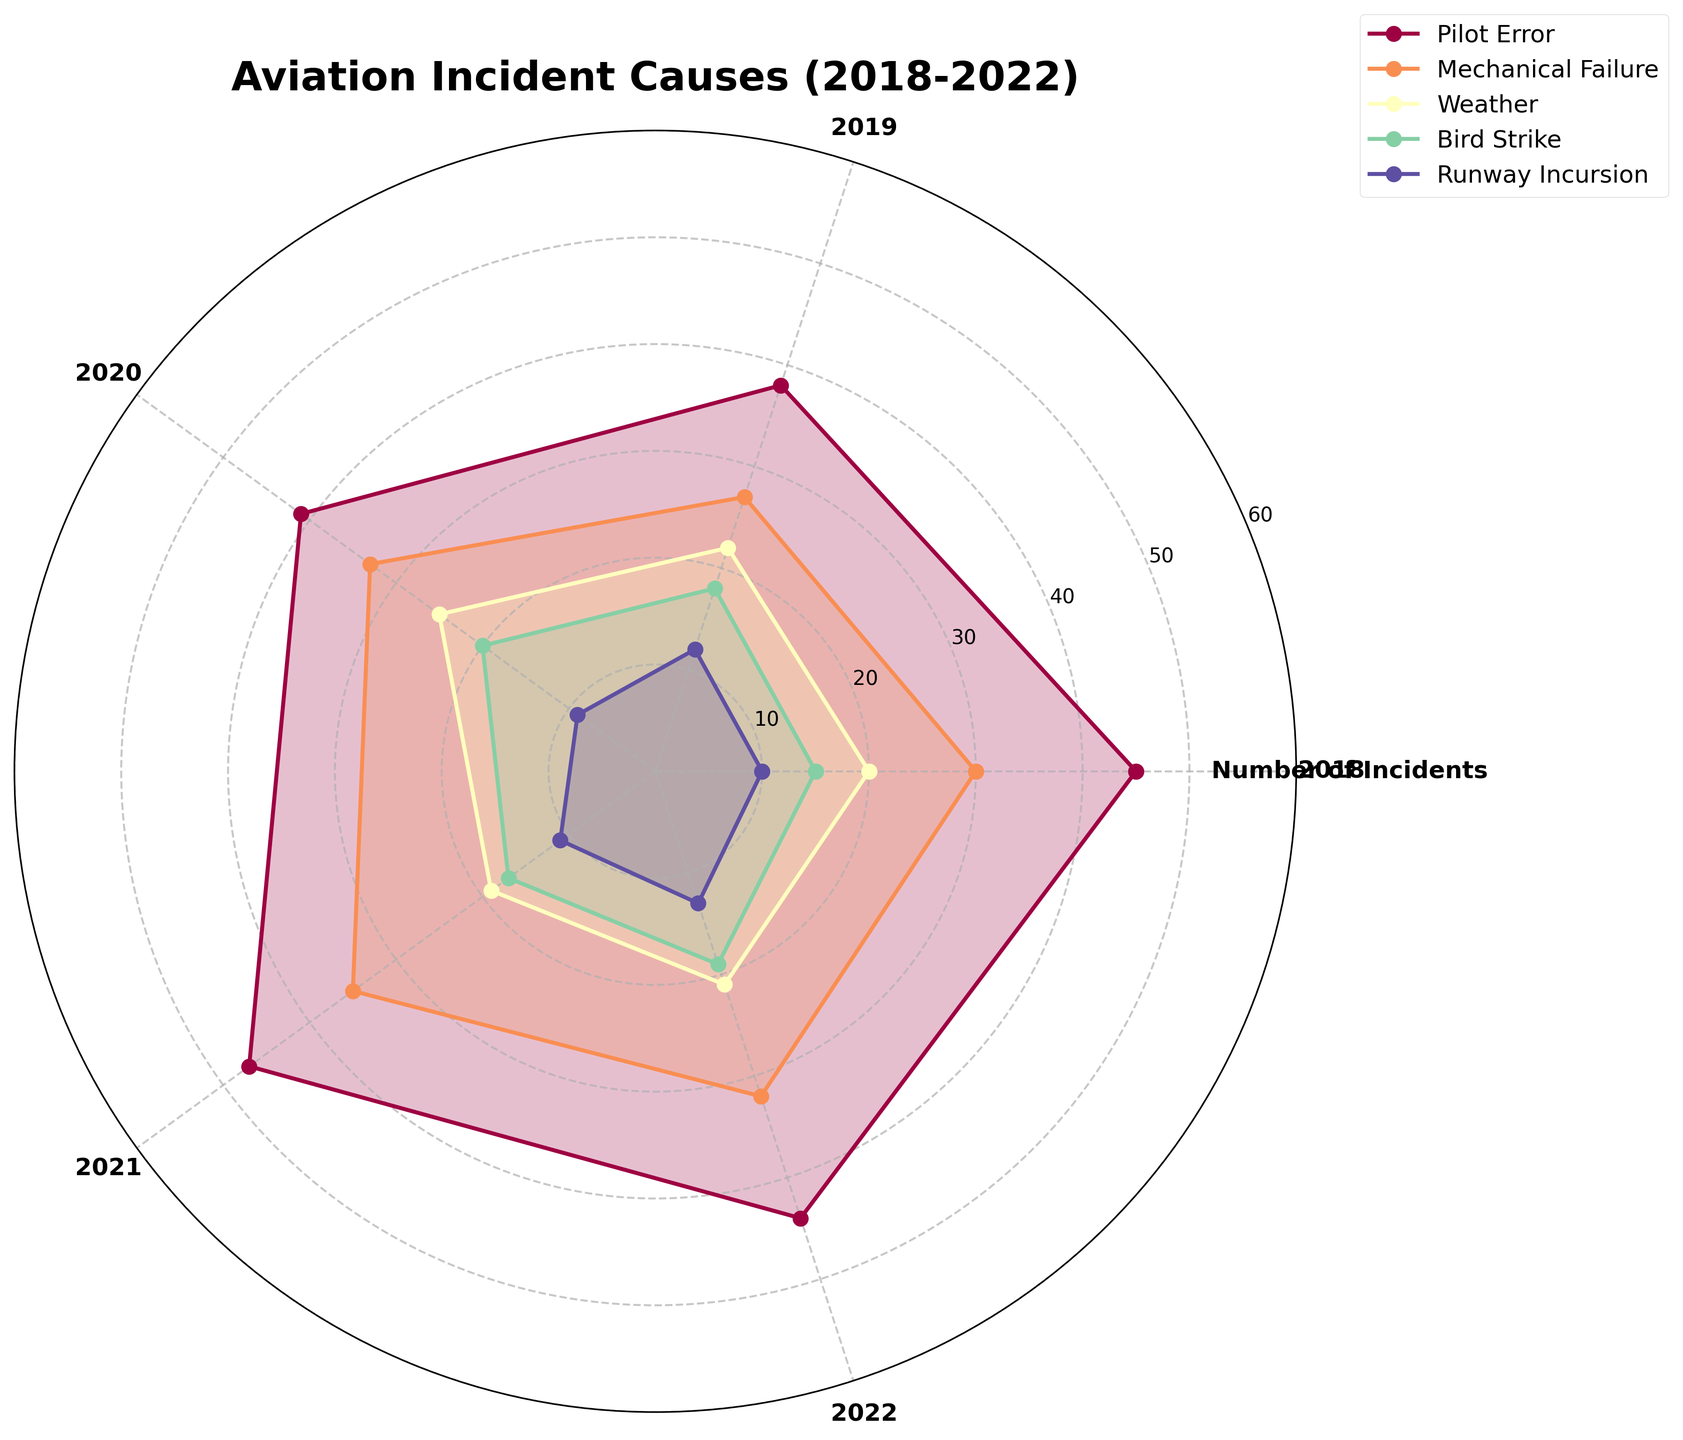What is the title of the chart? The title is always prominently displayed at the top of the chart, indicating the subject of the visualization
Answer: Aviation Incident Causes (2018-2022) How many incident categories are shown in the chart? Count the number of unique labels in the legend which typically matches the number of categories being visualized.
Answer: 5 Which year experienced the highest number of Pilot Error incidents? Identify the Pilot Error segment and check the year that extends the farthest from the center.
Answer: 2021 How does the number of Weather-related incidents in 2020 compare to 2021? Find the segments corresponding to Weather in 2020 and 2021 and compare their lengths from the center. The segment with a longer extension indicates more incidents.
Answer: Higher in 2020 What is the combined total of Mechanical Failure incidents in 2019 and 2020? Locate the Mechanical Failure segments for 2019 and 2020, then sum their values based on the chart's radial axis. For 2019: 27 incidents, for 2020: 33 incidents.
Answer: 60 In which year did Bird Strikes have the fewest incidents? Identify the Bird Strike segments for each year and find the one closest to the center.
Answer: 2018 What is the difference in the number of Runway Incursion incidents between 2018 and 2022? Locate the Runway Incursion segments for 2018 and 2022 and calculate the difference by subtracting the smaller value from the larger one.
Answer: 3 Which incident type had the most significant fluctuation over the years? Comparing the radial spread of each segment across the years helps in assessing the level of fluctuation or variability. The largest variability indicates the most significant fluctuation.
Answer: Pilot Error What trend is noticeable for Mechanical Failure incidents from 2018 to 2022? Analyze the trend by observing if the segment for Mechanical Failure incidents increases, decreases, or remains stable over the years.
Answer: Slightly increasing Which incident type consistently had the least number of incidents across the years? Identify the incident type segments per year and observe which type remains the closest to the center across all years.
Answer: Runway Incursion 